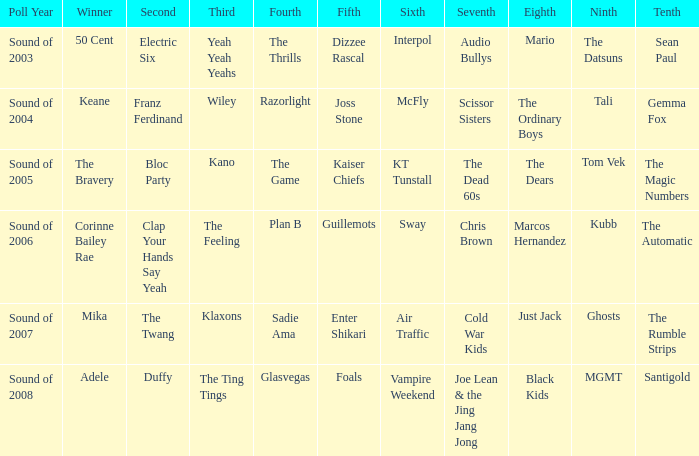If marcos hernandez is in the 8th position, who occupies the 6th position? Sway. 